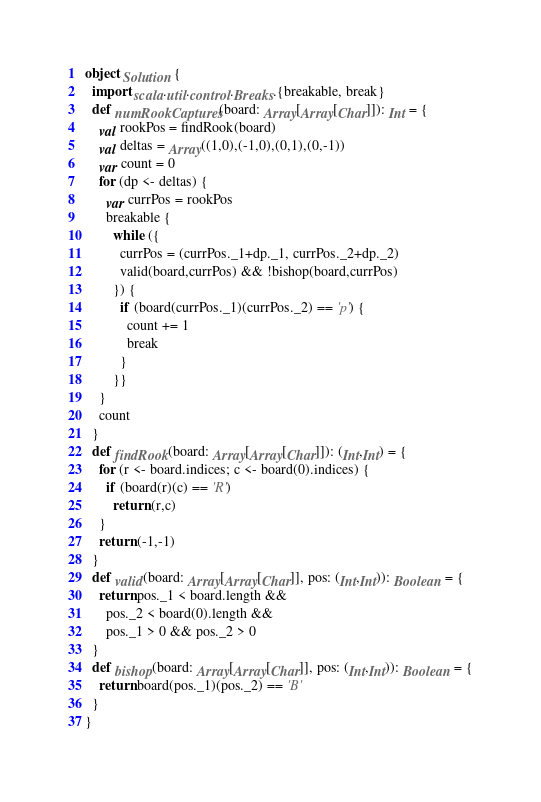Convert code to text. <code><loc_0><loc_0><loc_500><loc_500><_Scala_>object Solution {
  import scala.util.control.Breaks.{breakable, break}
  def numRookCaptures(board: Array[Array[Char]]): Int = {
    val rookPos = findRook(board)
    val deltas = Array((1,0),(-1,0),(0,1),(0,-1))
    var count = 0
    for (dp <- deltas) {
      var currPos = rookPos
      breakable {
        while ({
          currPos = (currPos._1+dp._1, currPos._2+dp._2)
          valid(board,currPos) && !bishop(board,currPos)
        }) {
          if (board(currPos._1)(currPos._2) == 'p') {
            count += 1
            break
          }
        }}
    }
    count
  }
  def findRook(board: Array[Array[Char]]): (Int,Int) = {
    for (r <- board.indices; c <- board(0).indices) {
      if (board(r)(c) == 'R')
        return (r,c)
    }
    return (-1,-1)
  }
  def valid(board: Array[Array[Char]], pos: (Int,Int)): Boolean = {
    return pos._1 < board.length &&
      pos._2 < board(0).length &&
      pos._1 > 0 && pos._2 > 0
  }
  def bishop(board: Array[Array[Char]], pos: (Int,Int)): Boolean = {
    return board(pos._1)(pos._2) == 'B'
  }
}</code> 